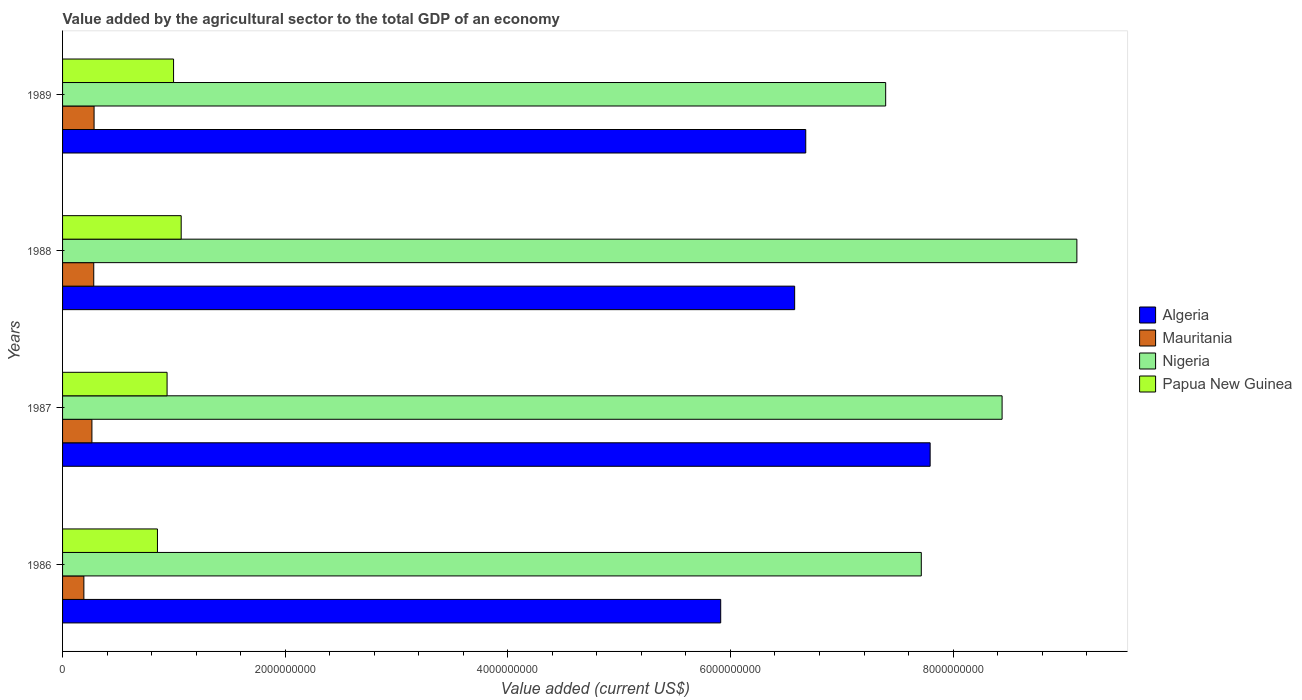How many groups of bars are there?
Offer a terse response. 4. Are the number of bars on each tick of the Y-axis equal?
Give a very brief answer. Yes. What is the value added by the agricultural sector to the total GDP in Mauritania in 1989?
Your answer should be very brief. 2.83e+08. Across all years, what is the maximum value added by the agricultural sector to the total GDP in Algeria?
Provide a short and direct response. 7.79e+09. Across all years, what is the minimum value added by the agricultural sector to the total GDP in Mauritania?
Keep it short and to the point. 1.91e+08. In which year was the value added by the agricultural sector to the total GDP in Mauritania minimum?
Your response must be concise. 1986. What is the total value added by the agricultural sector to the total GDP in Nigeria in the graph?
Keep it short and to the point. 3.27e+1. What is the difference between the value added by the agricultural sector to the total GDP in Nigeria in 1986 and that in 1988?
Ensure brevity in your answer.  -1.40e+09. What is the difference between the value added by the agricultural sector to the total GDP in Nigeria in 1987 and the value added by the agricultural sector to the total GDP in Mauritania in 1989?
Your answer should be very brief. 8.16e+09. What is the average value added by the agricultural sector to the total GDP in Papua New Guinea per year?
Give a very brief answer. 9.63e+08. In the year 1988, what is the difference between the value added by the agricultural sector to the total GDP in Algeria and value added by the agricultural sector to the total GDP in Nigeria?
Make the answer very short. -2.54e+09. What is the ratio of the value added by the agricultural sector to the total GDP in Papua New Guinea in 1986 to that in 1987?
Offer a very short reply. 0.91. Is the value added by the agricultural sector to the total GDP in Nigeria in 1987 less than that in 1988?
Offer a very short reply. Yes. Is the difference between the value added by the agricultural sector to the total GDP in Algeria in 1986 and 1988 greater than the difference between the value added by the agricultural sector to the total GDP in Nigeria in 1986 and 1988?
Keep it short and to the point. Yes. What is the difference between the highest and the second highest value added by the agricultural sector to the total GDP in Papua New Guinea?
Your response must be concise. 6.85e+07. What is the difference between the highest and the lowest value added by the agricultural sector to the total GDP in Nigeria?
Offer a terse response. 1.72e+09. In how many years, is the value added by the agricultural sector to the total GDP in Mauritania greater than the average value added by the agricultural sector to the total GDP in Mauritania taken over all years?
Your answer should be very brief. 3. Is the sum of the value added by the agricultural sector to the total GDP in Algeria in 1987 and 1989 greater than the maximum value added by the agricultural sector to the total GDP in Papua New Guinea across all years?
Your response must be concise. Yes. What does the 4th bar from the top in 1987 represents?
Offer a terse response. Algeria. What does the 1st bar from the bottom in 1988 represents?
Your response must be concise. Algeria. How many bars are there?
Provide a short and direct response. 16. What is the title of the graph?
Ensure brevity in your answer.  Value added by the agricultural sector to the total GDP of an economy. What is the label or title of the X-axis?
Provide a succinct answer. Value added (current US$). What is the label or title of the Y-axis?
Provide a succinct answer. Years. What is the Value added (current US$) of Algeria in 1986?
Offer a terse response. 5.91e+09. What is the Value added (current US$) of Mauritania in 1986?
Give a very brief answer. 1.91e+08. What is the Value added (current US$) in Nigeria in 1986?
Provide a short and direct response. 7.71e+09. What is the Value added (current US$) in Papua New Guinea in 1986?
Your response must be concise. 8.52e+08. What is the Value added (current US$) of Algeria in 1987?
Your response must be concise. 7.79e+09. What is the Value added (current US$) of Mauritania in 1987?
Offer a terse response. 2.64e+08. What is the Value added (current US$) of Nigeria in 1987?
Give a very brief answer. 8.44e+09. What is the Value added (current US$) of Papua New Guinea in 1987?
Offer a very short reply. 9.39e+08. What is the Value added (current US$) in Algeria in 1988?
Give a very brief answer. 6.58e+09. What is the Value added (current US$) in Mauritania in 1988?
Your response must be concise. 2.80e+08. What is the Value added (current US$) of Nigeria in 1988?
Offer a very short reply. 9.11e+09. What is the Value added (current US$) of Papua New Guinea in 1988?
Keep it short and to the point. 1.07e+09. What is the Value added (current US$) of Algeria in 1989?
Provide a succinct answer. 6.68e+09. What is the Value added (current US$) of Mauritania in 1989?
Ensure brevity in your answer.  2.83e+08. What is the Value added (current US$) of Nigeria in 1989?
Your answer should be very brief. 7.39e+09. What is the Value added (current US$) in Papua New Guinea in 1989?
Your answer should be very brief. 9.97e+08. Across all years, what is the maximum Value added (current US$) in Algeria?
Your answer should be very brief. 7.79e+09. Across all years, what is the maximum Value added (current US$) of Mauritania?
Your response must be concise. 2.83e+08. Across all years, what is the maximum Value added (current US$) of Nigeria?
Provide a short and direct response. 9.11e+09. Across all years, what is the maximum Value added (current US$) of Papua New Guinea?
Provide a short and direct response. 1.07e+09. Across all years, what is the minimum Value added (current US$) of Algeria?
Your response must be concise. 5.91e+09. Across all years, what is the minimum Value added (current US$) in Mauritania?
Your answer should be very brief. 1.91e+08. Across all years, what is the minimum Value added (current US$) in Nigeria?
Provide a short and direct response. 7.39e+09. Across all years, what is the minimum Value added (current US$) in Papua New Guinea?
Keep it short and to the point. 8.52e+08. What is the total Value added (current US$) in Algeria in the graph?
Your response must be concise. 2.70e+1. What is the total Value added (current US$) in Mauritania in the graph?
Provide a short and direct response. 1.02e+09. What is the total Value added (current US$) in Nigeria in the graph?
Your answer should be very brief. 3.27e+1. What is the total Value added (current US$) of Papua New Guinea in the graph?
Offer a terse response. 3.85e+09. What is the difference between the Value added (current US$) of Algeria in 1986 and that in 1987?
Offer a terse response. -1.88e+09. What is the difference between the Value added (current US$) of Mauritania in 1986 and that in 1987?
Keep it short and to the point. -7.23e+07. What is the difference between the Value added (current US$) in Nigeria in 1986 and that in 1987?
Provide a succinct answer. -7.26e+08. What is the difference between the Value added (current US$) in Papua New Guinea in 1986 and that in 1987?
Give a very brief answer. -8.65e+07. What is the difference between the Value added (current US$) of Algeria in 1986 and that in 1988?
Provide a succinct answer. -6.64e+08. What is the difference between the Value added (current US$) of Mauritania in 1986 and that in 1988?
Make the answer very short. -8.87e+07. What is the difference between the Value added (current US$) of Nigeria in 1986 and that in 1988?
Give a very brief answer. -1.40e+09. What is the difference between the Value added (current US$) in Papua New Guinea in 1986 and that in 1988?
Give a very brief answer. -2.13e+08. What is the difference between the Value added (current US$) in Algeria in 1986 and that in 1989?
Give a very brief answer. -7.64e+08. What is the difference between the Value added (current US$) in Mauritania in 1986 and that in 1989?
Provide a short and direct response. -9.16e+07. What is the difference between the Value added (current US$) in Nigeria in 1986 and that in 1989?
Keep it short and to the point. 3.20e+08. What is the difference between the Value added (current US$) in Papua New Guinea in 1986 and that in 1989?
Offer a terse response. -1.45e+08. What is the difference between the Value added (current US$) in Algeria in 1987 and that in 1988?
Offer a terse response. 1.22e+09. What is the difference between the Value added (current US$) of Mauritania in 1987 and that in 1988?
Provide a succinct answer. -1.64e+07. What is the difference between the Value added (current US$) of Nigeria in 1987 and that in 1988?
Offer a very short reply. -6.72e+08. What is the difference between the Value added (current US$) of Papua New Guinea in 1987 and that in 1988?
Your answer should be compact. -1.27e+08. What is the difference between the Value added (current US$) in Algeria in 1987 and that in 1989?
Offer a terse response. 1.12e+09. What is the difference between the Value added (current US$) in Mauritania in 1987 and that in 1989?
Ensure brevity in your answer.  -1.93e+07. What is the difference between the Value added (current US$) of Nigeria in 1987 and that in 1989?
Offer a very short reply. 1.05e+09. What is the difference between the Value added (current US$) in Papua New Guinea in 1987 and that in 1989?
Your response must be concise. -5.82e+07. What is the difference between the Value added (current US$) of Algeria in 1988 and that in 1989?
Keep it short and to the point. -9.96e+07. What is the difference between the Value added (current US$) of Mauritania in 1988 and that in 1989?
Provide a succinct answer. -2.93e+06. What is the difference between the Value added (current US$) in Nigeria in 1988 and that in 1989?
Give a very brief answer. 1.72e+09. What is the difference between the Value added (current US$) in Papua New Guinea in 1988 and that in 1989?
Your answer should be very brief. 6.85e+07. What is the difference between the Value added (current US$) in Algeria in 1986 and the Value added (current US$) in Mauritania in 1987?
Your response must be concise. 5.65e+09. What is the difference between the Value added (current US$) in Algeria in 1986 and the Value added (current US$) in Nigeria in 1987?
Give a very brief answer. -2.53e+09. What is the difference between the Value added (current US$) of Algeria in 1986 and the Value added (current US$) of Papua New Guinea in 1987?
Make the answer very short. 4.97e+09. What is the difference between the Value added (current US$) of Mauritania in 1986 and the Value added (current US$) of Nigeria in 1987?
Keep it short and to the point. -8.25e+09. What is the difference between the Value added (current US$) of Mauritania in 1986 and the Value added (current US$) of Papua New Guinea in 1987?
Provide a short and direct response. -7.47e+08. What is the difference between the Value added (current US$) in Nigeria in 1986 and the Value added (current US$) in Papua New Guinea in 1987?
Your answer should be compact. 6.78e+09. What is the difference between the Value added (current US$) in Algeria in 1986 and the Value added (current US$) in Mauritania in 1988?
Provide a short and direct response. 5.63e+09. What is the difference between the Value added (current US$) of Algeria in 1986 and the Value added (current US$) of Nigeria in 1988?
Offer a very short reply. -3.20e+09. What is the difference between the Value added (current US$) of Algeria in 1986 and the Value added (current US$) of Papua New Guinea in 1988?
Provide a succinct answer. 4.85e+09. What is the difference between the Value added (current US$) in Mauritania in 1986 and the Value added (current US$) in Nigeria in 1988?
Provide a succinct answer. -8.92e+09. What is the difference between the Value added (current US$) in Mauritania in 1986 and the Value added (current US$) in Papua New Guinea in 1988?
Offer a very short reply. -8.74e+08. What is the difference between the Value added (current US$) in Nigeria in 1986 and the Value added (current US$) in Papua New Guinea in 1988?
Offer a very short reply. 6.65e+09. What is the difference between the Value added (current US$) in Algeria in 1986 and the Value added (current US$) in Mauritania in 1989?
Make the answer very short. 5.63e+09. What is the difference between the Value added (current US$) in Algeria in 1986 and the Value added (current US$) in Nigeria in 1989?
Make the answer very short. -1.48e+09. What is the difference between the Value added (current US$) in Algeria in 1986 and the Value added (current US$) in Papua New Guinea in 1989?
Ensure brevity in your answer.  4.92e+09. What is the difference between the Value added (current US$) in Mauritania in 1986 and the Value added (current US$) in Nigeria in 1989?
Your answer should be compact. -7.20e+09. What is the difference between the Value added (current US$) in Mauritania in 1986 and the Value added (current US$) in Papua New Guinea in 1989?
Make the answer very short. -8.06e+08. What is the difference between the Value added (current US$) in Nigeria in 1986 and the Value added (current US$) in Papua New Guinea in 1989?
Offer a very short reply. 6.72e+09. What is the difference between the Value added (current US$) in Algeria in 1987 and the Value added (current US$) in Mauritania in 1988?
Your answer should be compact. 7.51e+09. What is the difference between the Value added (current US$) in Algeria in 1987 and the Value added (current US$) in Nigeria in 1988?
Provide a succinct answer. -1.32e+09. What is the difference between the Value added (current US$) of Algeria in 1987 and the Value added (current US$) of Papua New Guinea in 1988?
Give a very brief answer. 6.73e+09. What is the difference between the Value added (current US$) in Mauritania in 1987 and the Value added (current US$) in Nigeria in 1988?
Give a very brief answer. -8.85e+09. What is the difference between the Value added (current US$) of Mauritania in 1987 and the Value added (current US$) of Papua New Guinea in 1988?
Offer a very short reply. -8.02e+08. What is the difference between the Value added (current US$) of Nigeria in 1987 and the Value added (current US$) of Papua New Guinea in 1988?
Keep it short and to the point. 7.37e+09. What is the difference between the Value added (current US$) in Algeria in 1987 and the Value added (current US$) in Mauritania in 1989?
Offer a very short reply. 7.51e+09. What is the difference between the Value added (current US$) of Algeria in 1987 and the Value added (current US$) of Nigeria in 1989?
Provide a succinct answer. 4.00e+08. What is the difference between the Value added (current US$) of Algeria in 1987 and the Value added (current US$) of Papua New Guinea in 1989?
Keep it short and to the point. 6.80e+09. What is the difference between the Value added (current US$) of Mauritania in 1987 and the Value added (current US$) of Nigeria in 1989?
Offer a very short reply. -7.13e+09. What is the difference between the Value added (current US$) of Mauritania in 1987 and the Value added (current US$) of Papua New Guinea in 1989?
Your response must be concise. -7.33e+08. What is the difference between the Value added (current US$) in Nigeria in 1987 and the Value added (current US$) in Papua New Guinea in 1989?
Ensure brevity in your answer.  7.44e+09. What is the difference between the Value added (current US$) in Algeria in 1988 and the Value added (current US$) in Mauritania in 1989?
Provide a short and direct response. 6.29e+09. What is the difference between the Value added (current US$) in Algeria in 1988 and the Value added (current US$) in Nigeria in 1989?
Offer a terse response. -8.18e+08. What is the difference between the Value added (current US$) in Algeria in 1988 and the Value added (current US$) in Papua New Guinea in 1989?
Provide a succinct answer. 5.58e+09. What is the difference between the Value added (current US$) in Mauritania in 1988 and the Value added (current US$) in Nigeria in 1989?
Give a very brief answer. -7.11e+09. What is the difference between the Value added (current US$) in Mauritania in 1988 and the Value added (current US$) in Papua New Guinea in 1989?
Give a very brief answer. -7.17e+08. What is the difference between the Value added (current US$) of Nigeria in 1988 and the Value added (current US$) of Papua New Guinea in 1989?
Your response must be concise. 8.11e+09. What is the average Value added (current US$) of Algeria per year?
Offer a terse response. 6.74e+09. What is the average Value added (current US$) of Mauritania per year?
Your response must be concise. 2.55e+08. What is the average Value added (current US$) of Nigeria per year?
Your answer should be very brief. 8.17e+09. What is the average Value added (current US$) of Papua New Guinea per year?
Offer a very short reply. 9.63e+08. In the year 1986, what is the difference between the Value added (current US$) of Algeria and Value added (current US$) of Mauritania?
Your answer should be compact. 5.72e+09. In the year 1986, what is the difference between the Value added (current US$) of Algeria and Value added (current US$) of Nigeria?
Your response must be concise. -1.80e+09. In the year 1986, what is the difference between the Value added (current US$) of Algeria and Value added (current US$) of Papua New Guinea?
Your answer should be compact. 5.06e+09. In the year 1986, what is the difference between the Value added (current US$) in Mauritania and Value added (current US$) in Nigeria?
Your response must be concise. -7.52e+09. In the year 1986, what is the difference between the Value added (current US$) of Mauritania and Value added (current US$) of Papua New Guinea?
Your answer should be compact. -6.61e+08. In the year 1986, what is the difference between the Value added (current US$) in Nigeria and Value added (current US$) in Papua New Guinea?
Your response must be concise. 6.86e+09. In the year 1987, what is the difference between the Value added (current US$) of Algeria and Value added (current US$) of Mauritania?
Your response must be concise. 7.53e+09. In the year 1987, what is the difference between the Value added (current US$) in Algeria and Value added (current US$) in Nigeria?
Keep it short and to the point. -6.46e+08. In the year 1987, what is the difference between the Value added (current US$) in Algeria and Value added (current US$) in Papua New Guinea?
Ensure brevity in your answer.  6.85e+09. In the year 1987, what is the difference between the Value added (current US$) in Mauritania and Value added (current US$) in Nigeria?
Offer a terse response. -8.18e+09. In the year 1987, what is the difference between the Value added (current US$) of Mauritania and Value added (current US$) of Papua New Guinea?
Offer a very short reply. -6.75e+08. In the year 1987, what is the difference between the Value added (current US$) of Nigeria and Value added (current US$) of Papua New Guinea?
Give a very brief answer. 7.50e+09. In the year 1988, what is the difference between the Value added (current US$) of Algeria and Value added (current US$) of Mauritania?
Offer a very short reply. 6.30e+09. In the year 1988, what is the difference between the Value added (current US$) of Algeria and Value added (current US$) of Nigeria?
Your answer should be compact. -2.54e+09. In the year 1988, what is the difference between the Value added (current US$) in Algeria and Value added (current US$) in Papua New Guinea?
Provide a succinct answer. 5.51e+09. In the year 1988, what is the difference between the Value added (current US$) in Mauritania and Value added (current US$) in Nigeria?
Ensure brevity in your answer.  -8.83e+09. In the year 1988, what is the difference between the Value added (current US$) of Mauritania and Value added (current US$) of Papua New Guinea?
Your response must be concise. -7.85e+08. In the year 1988, what is the difference between the Value added (current US$) of Nigeria and Value added (current US$) of Papua New Guinea?
Make the answer very short. 8.05e+09. In the year 1989, what is the difference between the Value added (current US$) in Algeria and Value added (current US$) in Mauritania?
Offer a terse response. 6.39e+09. In the year 1989, what is the difference between the Value added (current US$) of Algeria and Value added (current US$) of Nigeria?
Your answer should be very brief. -7.18e+08. In the year 1989, what is the difference between the Value added (current US$) in Algeria and Value added (current US$) in Papua New Guinea?
Keep it short and to the point. 5.68e+09. In the year 1989, what is the difference between the Value added (current US$) in Mauritania and Value added (current US$) in Nigeria?
Offer a terse response. -7.11e+09. In the year 1989, what is the difference between the Value added (current US$) in Mauritania and Value added (current US$) in Papua New Guinea?
Offer a terse response. -7.14e+08. In the year 1989, what is the difference between the Value added (current US$) of Nigeria and Value added (current US$) of Papua New Guinea?
Keep it short and to the point. 6.40e+09. What is the ratio of the Value added (current US$) in Algeria in 1986 to that in 1987?
Keep it short and to the point. 0.76. What is the ratio of the Value added (current US$) in Mauritania in 1986 to that in 1987?
Your answer should be very brief. 0.73. What is the ratio of the Value added (current US$) in Nigeria in 1986 to that in 1987?
Make the answer very short. 0.91. What is the ratio of the Value added (current US$) in Papua New Guinea in 1986 to that in 1987?
Your answer should be compact. 0.91. What is the ratio of the Value added (current US$) in Algeria in 1986 to that in 1988?
Give a very brief answer. 0.9. What is the ratio of the Value added (current US$) of Mauritania in 1986 to that in 1988?
Give a very brief answer. 0.68. What is the ratio of the Value added (current US$) of Nigeria in 1986 to that in 1988?
Provide a short and direct response. 0.85. What is the ratio of the Value added (current US$) in Papua New Guinea in 1986 to that in 1988?
Offer a very short reply. 0.8. What is the ratio of the Value added (current US$) of Algeria in 1986 to that in 1989?
Your response must be concise. 0.89. What is the ratio of the Value added (current US$) of Mauritania in 1986 to that in 1989?
Give a very brief answer. 0.68. What is the ratio of the Value added (current US$) in Nigeria in 1986 to that in 1989?
Give a very brief answer. 1.04. What is the ratio of the Value added (current US$) of Papua New Guinea in 1986 to that in 1989?
Provide a succinct answer. 0.85. What is the ratio of the Value added (current US$) of Algeria in 1987 to that in 1988?
Keep it short and to the point. 1.19. What is the ratio of the Value added (current US$) in Mauritania in 1987 to that in 1988?
Keep it short and to the point. 0.94. What is the ratio of the Value added (current US$) of Nigeria in 1987 to that in 1988?
Offer a very short reply. 0.93. What is the ratio of the Value added (current US$) in Papua New Guinea in 1987 to that in 1988?
Keep it short and to the point. 0.88. What is the ratio of the Value added (current US$) in Algeria in 1987 to that in 1989?
Ensure brevity in your answer.  1.17. What is the ratio of the Value added (current US$) in Mauritania in 1987 to that in 1989?
Give a very brief answer. 0.93. What is the ratio of the Value added (current US$) of Nigeria in 1987 to that in 1989?
Your answer should be very brief. 1.14. What is the ratio of the Value added (current US$) in Papua New Guinea in 1987 to that in 1989?
Give a very brief answer. 0.94. What is the ratio of the Value added (current US$) of Algeria in 1988 to that in 1989?
Provide a short and direct response. 0.99. What is the ratio of the Value added (current US$) in Nigeria in 1988 to that in 1989?
Offer a very short reply. 1.23. What is the ratio of the Value added (current US$) in Papua New Guinea in 1988 to that in 1989?
Provide a succinct answer. 1.07. What is the difference between the highest and the second highest Value added (current US$) in Algeria?
Make the answer very short. 1.12e+09. What is the difference between the highest and the second highest Value added (current US$) in Mauritania?
Keep it short and to the point. 2.93e+06. What is the difference between the highest and the second highest Value added (current US$) in Nigeria?
Offer a very short reply. 6.72e+08. What is the difference between the highest and the second highest Value added (current US$) in Papua New Guinea?
Provide a succinct answer. 6.85e+07. What is the difference between the highest and the lowest Value added (current US$) of Algeria?
Provide a succinct answer. 1.88e+09. What is the difference between the highest and the lowest Value added (current US$) in Mauritania?
Make the answer very short. 9.16e+07. What is the difference between the highest and the lowest Value added (current US$) in Nigeria?
Provide a succinct answer. 1.72e+09. What is the difference between the highest and the lowest Value added (current US$) in Papua New Guinea?
Offer a terse response. 2.13e+08. 